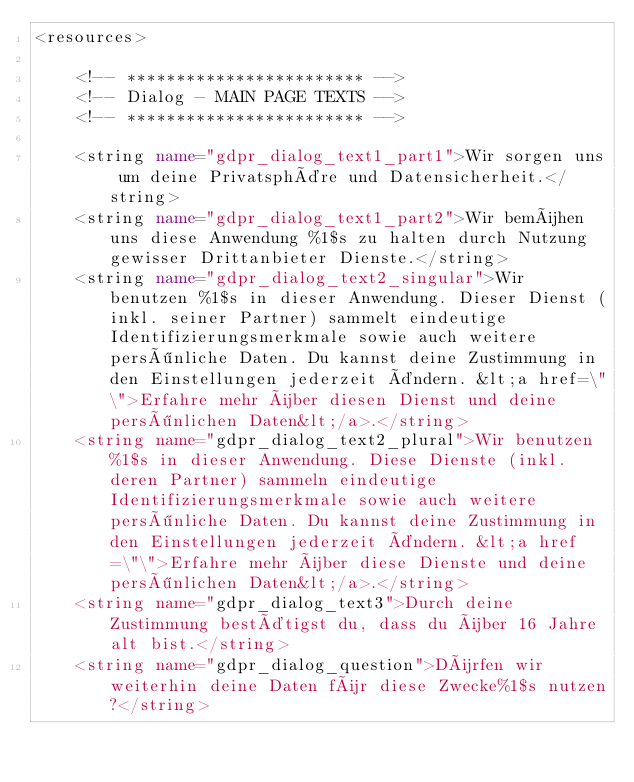Convert code to text. <code><loc_0><loc_0><loc_500><loc_500><_XML_><resources>

    <!-- ************************ -->
    <!-- Dialog - MAIN PAGE TEXTS -->
    <!-- ************************ -->

    <string name="gdpr_dialog_text1_part1">Wir sorgen uns um deine Privatsphäre und Datensicherheit.</string>
    <string name="gdpr_dialog_text1_part2">Wir bemühen uns diese Anwendung %1$s zu halten durch Nutzung gewisser Drittanbieter Dienste.</string>
    <string name="gdpr_dialog_text2_singular">Wir benutzen %1$s in dieser Anwendung. Dieser Dienst (inkl. seiner Partner) sammelt eindeutige Identifizierungsmerkmale sowie auch weitere persönliche Daten. Du kannst deine Zustimmung in den Einstellungen jederzeit ändern. &lt;a href=\"\">Erfahre mehr über diesen Dienst und deine persönlichen Daten&lt;/a>.</string>
    <string name="gdpr_dialog_text2_plural">Wir benutzen %1$s in dieser Anwendung. Diese Dienste (inkl. deren Partner) sammeln eindeutige Identifizierungsmerkmale sowie auch weitere persönliche Daten. Du kannst deine Zustimmung in den Einstellungen jederzeit ändern. &lt;a href=\"\">Erfahre mehr über diese Dienste und deine persönlichen Daten&lt;/a>.</string>
    <string name="gdpr_dialog_text3">Durch deine Zustimmung bestätigst du, dass du über 16 Jahre alt bist.</string>
    <string name="gdpr_dialog_question">Dürfen wir weiterhin deine Daten für diese Zwecke%1$s nutzen?</string></code> 